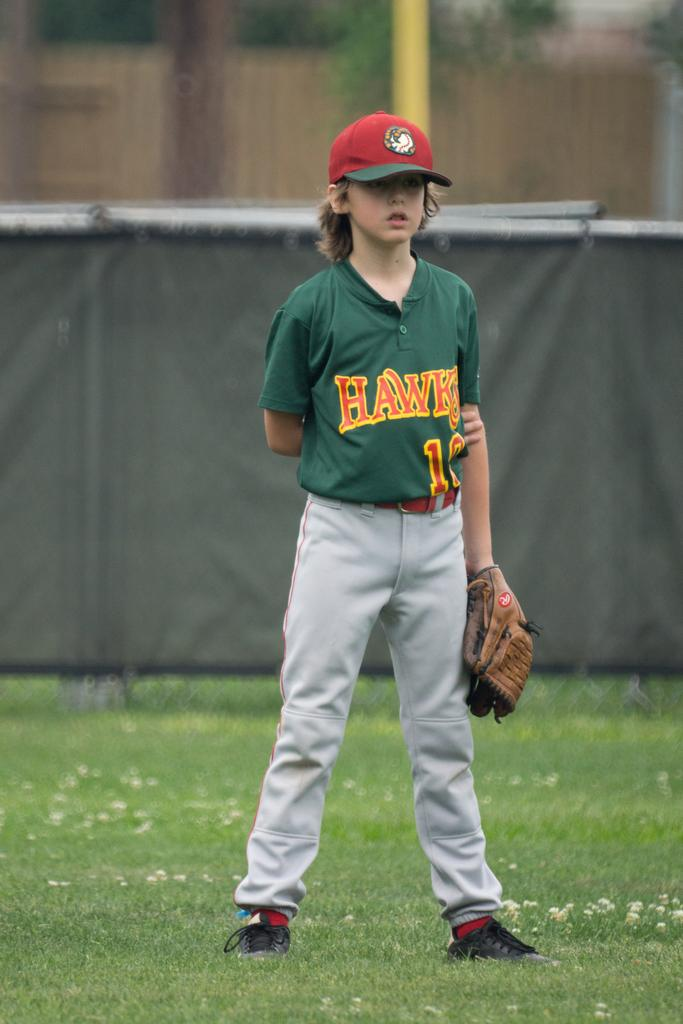Provide a one-sentence caption for the provided image. A young baseball player stands on the field wearing a green Hawks jersey/. 